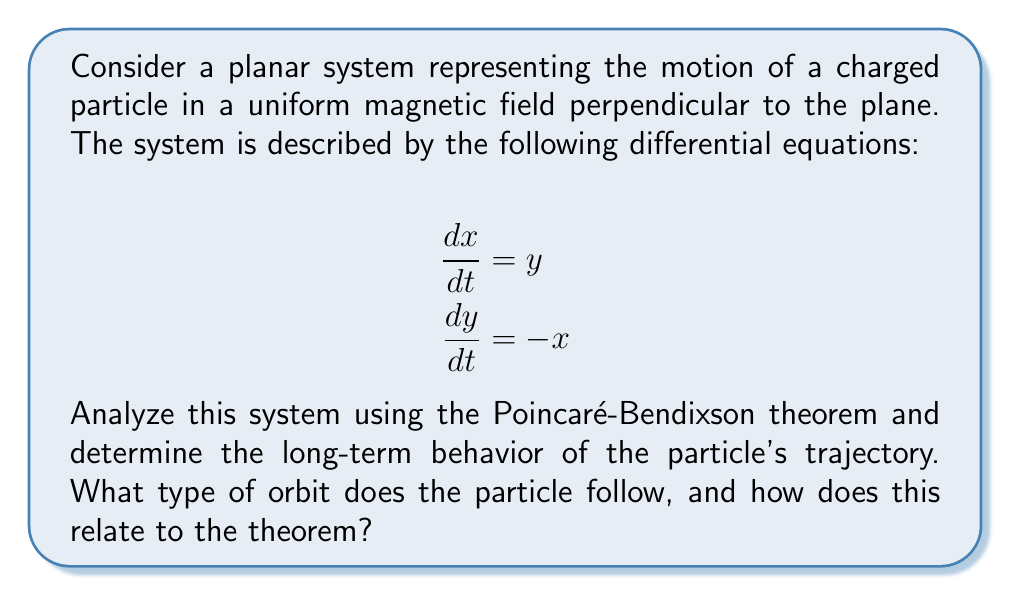Can you solve this math problem? Let's approach this step-by-step:

1) First, we need to identify the phase plane of the system. The phase plane is the $xy$-plane, where $x$ and $y$ represent the particle's position.

2) The vector field of the system is given by $\mathbf{F}(x,y) = (y, -x)$. We can visualize this as:

   [asy]
   import graph;
   size(200);
   
   void arrow(pair A, pair B, pen p=currentpen)
   {
     draw(A--B,p,Arrow(TeXHead));
   }
   
   for(int i=-2; i<=2; ++i)
     for(int j=-2; j<=2; ++j)
       arrow((i,j), (i+0.3*j, j-0.3*i), blue);
   
   xaxis(arrow=Arrow(TeXHead));
   yaxis(arrow=Arrow(TeXHead));
   label("$x$", (2.2,0), E);
   label("$y$", (0,2.2), N);
   [/asy]

3) To apply the Poincaré-Bendixson theorem, we need to check if:
   a) The system is planar (which it is)
   b) The vector field is continuously differentiable (which it is)
   c) There exists a closed, bounded subset of the plane that the trajectory cannot leave

4) For point c, we can use the fact that this system represents simple harmonic motion. The solution to this system is:

   $$x(t) = A \cos(t + \phi)$$
   $$y(t) = A \sin(t + \phi)$$

   where $A$ and $\phi$ are constants determined by initial conditions.

5) This solution describes circular motion with radius $A$. For any initial condition, the trajectory will be confined to a circle, which is a closed, bounded subset of the plane.

6) The Poincaré-Bendixson theorem states that if a trajectory is confined to a closed, bounded subset of the plane, it must either:
   a) Approach a fixed point
   b) Approach a periodic orbit
   c) Be a periodic orbit itself

7) In this case, there are no fixed points (the origin is not a fixed point as the particle doesn't stop there), and the trajectory itself is a periodic orbit.

8) Therefore, by the Poincaré-Bendixson theorem, the long-term behavior of the particle's trajectory must be a periodic orbit, which in this case is a circle.

9) This circular motion represents the cyclotron motion of a charged particle in a uniform magnetic field, which is perpendicular to the plane of motion.
Answer: Circular periodic orbit 